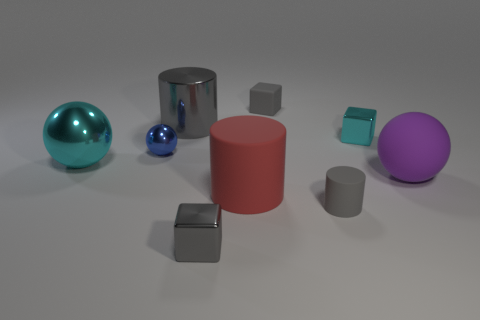What number of gray cylinders have the same material as the tiny cyan object?
Offer a very short reply. 1. There is a tiny cylinder that is made of the same material as the large red object; what is its color?
Give a very brief answer. Gray. Do the tiny cube that is on the left side of the matte block and the metal cylinder have the same color?
Ensure brevity in your answer.  Yes. What material is the ball right of the tiny blue shiny sphere?
Your answer should be compact. Rubber. Are there an equal number of matte cylinders on the left side of the red cylinder and large gray cylinders?
Give a very brief answer. No. How many large shiny cylinders are the same color as the tiny rubber block?
Make the answer very short. 1. What color is the other big matte thing that is the same shape as the large cyan thing?
Provide a short and direct response. Purple. Do the cyan metallic sphere and the gray matte cube have the same size?
Give a very brief answer. No. Are there the same number of large red cylinders that are behind the blue shiny thing and large metallic balls in front of the large gray object?
Provide a succinct answer. No. Are any yellow cylinders visible?
Provide a succinct answer. No. 